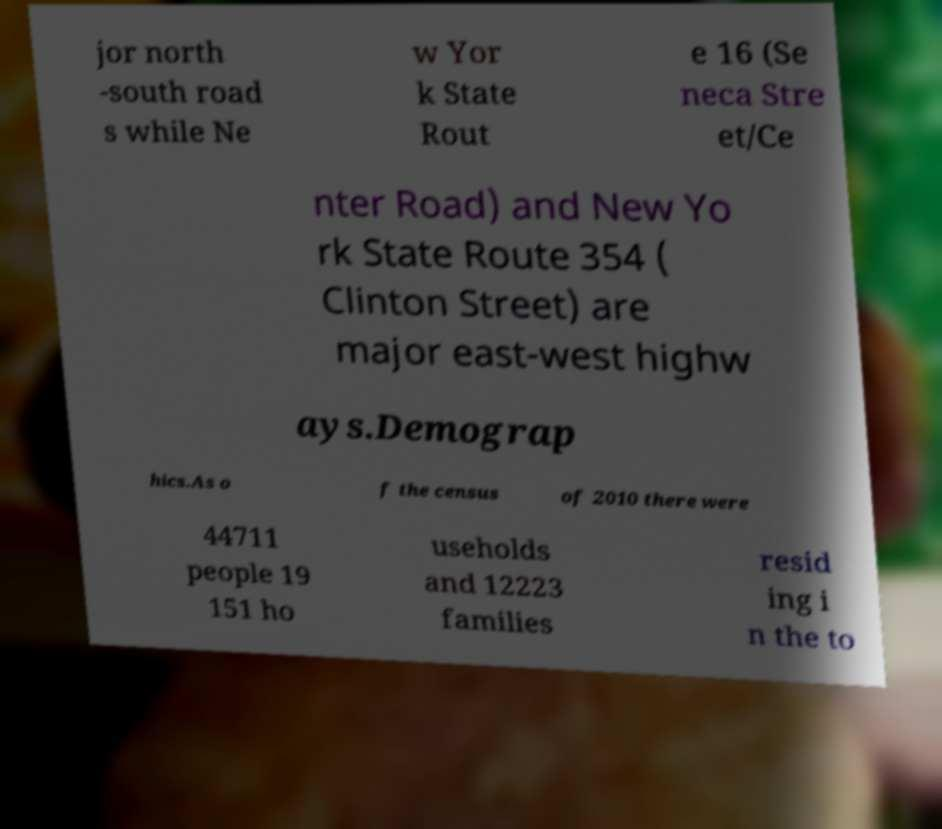Can you read and provide the text displayed in the image?This photo seems to have some interesting text. Can you extract and type it out for me? jor north -south road s while Ne w Yor k State Rout e 16 (Se neca Stre et/Ce nter Road) and New Yo rk State Route 354 ( Clinton Street) are major east-west highw ays.Demograp hics.As o f the census of 2010 there were 44711 people 19 151 ho useholds and 12223 families resid ing i n the to 